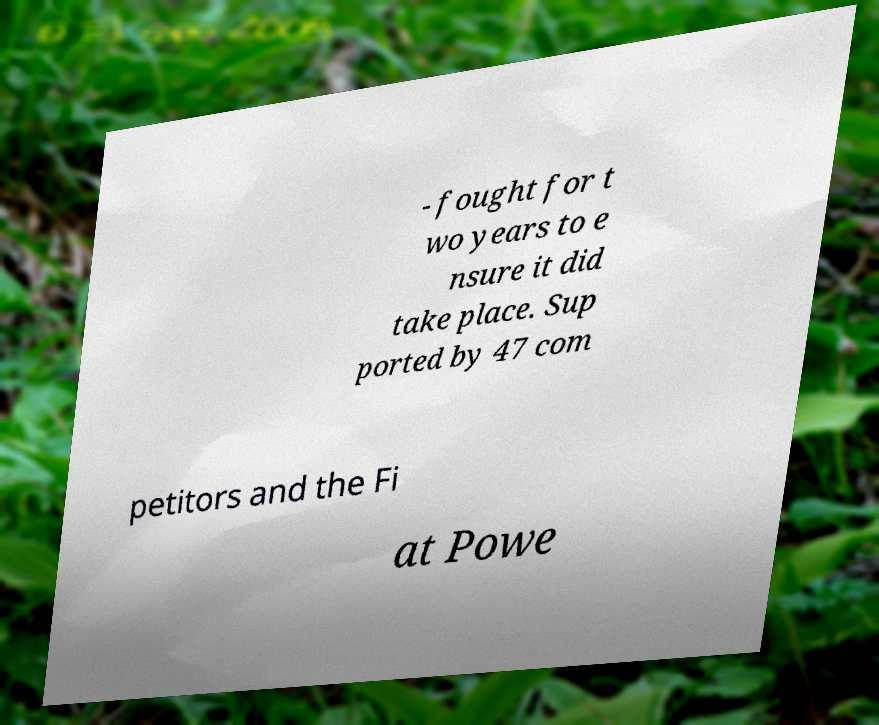What messages or text are displayed in this image? I need them in a readable, typed format. - fought for t wo years to e nsure it did take place. Sup ported by 47 com petitors and the Fi at Powe 